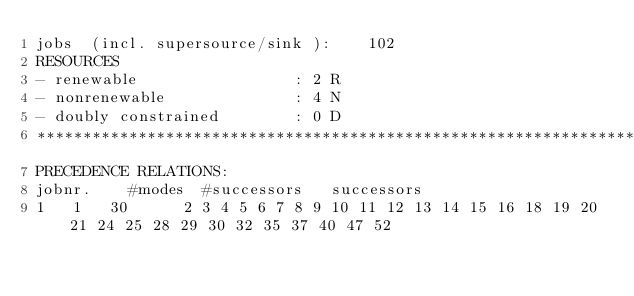<code> <loc_0><loc_0><loc_500><loc_500><_ObjectiveC_>jobs  (incl. supersource/sink ):	102
RESOURCES
- renewable                 : 2 R
- nonrenewable              : 4 N
- doubly constrained        : 0 D
************************************************************************
PRECEDENCE RELATIONS:
jobnr.    #modes  #successors   successors
1	1	30		2 3 4 5 6 7 8 9 10 11 12 13 14 15 16 18 19 20 21 24 25 28 29 30 32 35 37 40 47 52 </code> 